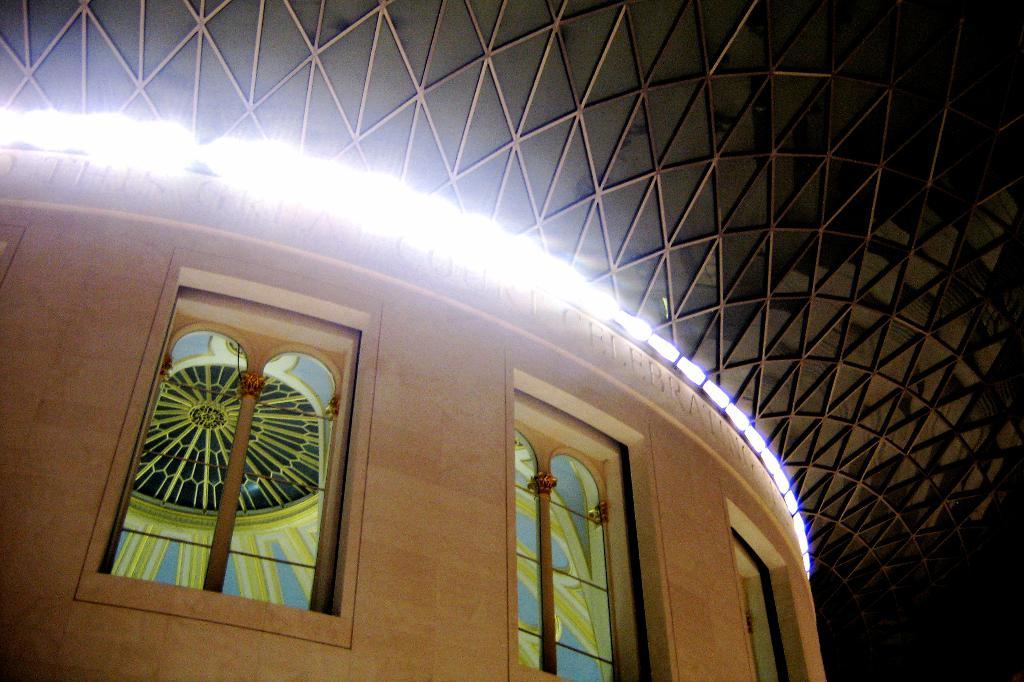What is located at the bottom of the image? There is a wall at the bottom of the image. What can be seen in the image besides the wall? There are windows, text on the wall, lights, and a roof at the top of the image. Can you describe the windows in the image? The windows are visible in the image, but their specific characteristics are not mentioned in the provided facts. What is the purpose of the lights in the image? The purpose of the lights in the image is not mentioned in the provided facts. Where are the chickens located in the image? There are no chickens present in the image. What type of pot is used to hold the celery in the image? There is no celery or pot present in the image. 